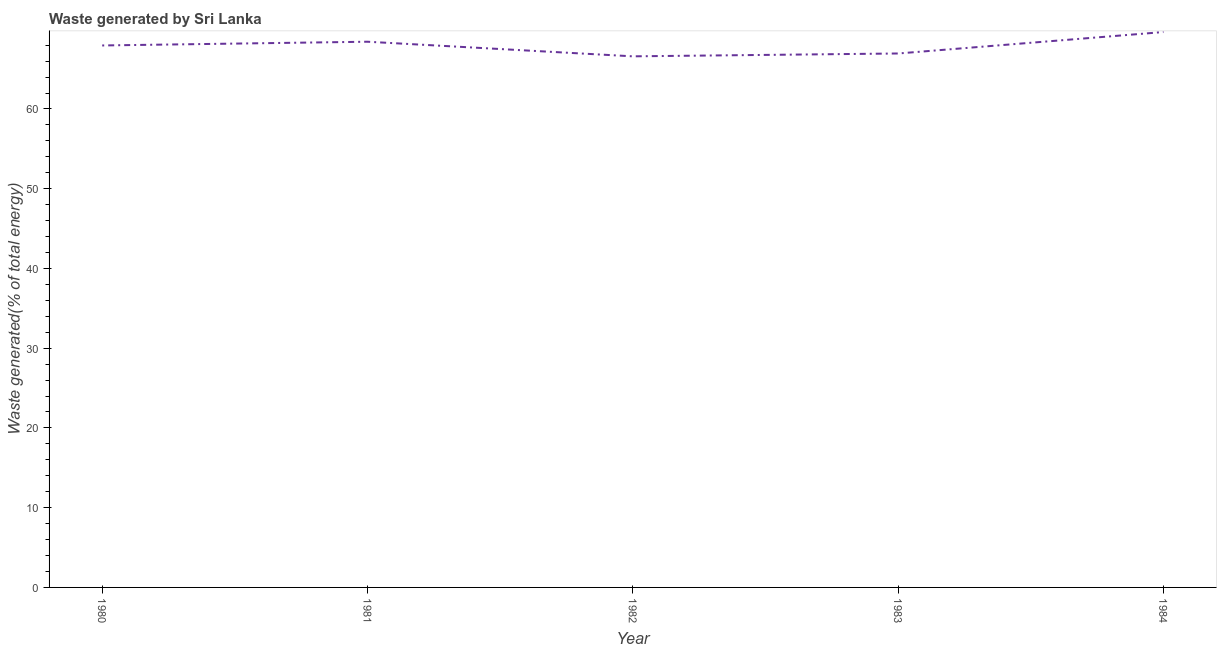What is the amount of waste generated in 1983?
Provide a succinct answer. 66.96. Across all years, what is the maximum amount of waste generated?
Ensure brevity in your answer.  69.64. Across all years, what is the minimum amount of waste generated?
Make the answer very short. 66.6. What is the sum of the amount of waste generated?
Your answer should be very brief. 339.59. What is the difference between the amount of waste generated in 1981 and 1983?
Keep it short and to the point. 1.47. What is the average amount of waste generated per year?
Your answer should be compact. 67.92. What is the median amount of waste generated?
Provide a succinct answer. 67.96. In how many years, is the amount of waste generated greater than 64 %?
Give a very brief answer. 5. What is the ratio of the amount of waste generated in 1982 to that in 1984?
Keep it short and to the point. 0.96. Is the difference between the amount of waste generated in 1980 and 1981 greater than the difference between any two years?
Make the answer very short. No. What is the difference between the highest and the second highest amount of waste generated?
Offer a terse response. 1.21. What is the difference between the highest and the lowest amount of waste generated?
Your response must be concise. 3.05. Does the amount of waste generated monotonically increase over the years?
Your response must be concise. No. How many lines are there?
Your response must be concise. 1. Are the values on the major ticks of Y-axis written in scientific E-notation?
Give a very brief answer. No. Does the graph contain any zero values?
Offer a very short reply. No. What is the title of the graph?
Keep it short and to the point. Waste generated by Sri Lanka. What is the label or title of the X-axis?
Keep it short and to the point. Year. What is the label or title of the Y-axis?
Offer a very short reply. Waste generated(% of total energy). What is the Waste generated(% of total energy) of 1980?
Offer a terse response. 67.96. What is the Waste generated(% of total energy) of 1981?
Your answer should be compact. 68.43. What is the Waste generated(% of total energy) of 1982?
Make the answer very short. 66.6. What is the Waste generated(% of total energy) in 1983?
Your answer should be very brief. 66.96. What is the Waste generated(% of total energy) of 1984?
Provide a succinct answer. 69.64. What is the difference between the Waste generated(% of total energy) in 1980 and 1981?
Provide a short and direct response. -0.47. What is the difference between the Waste generated(% of total energy) in 1980 and 1982?
Offer a terse response. 1.36. What is the difference between the Waste generated(% of total energy) in 1980 and 1983?
Your answer should be very brief. 1.01. What is the difference between the Waste generated(% of total energy) in 1980 and 1984?
Your answer should be very brief. -1.68. What is the difference between the Waste generated(% of total energy) in 1981 and 1982?
Keep it short and to the point. 1.83. What is the difference between the Waste generated(% of total energy) in 1981 and 1983?
Provide a succinct answer. 1.47. What is the difference between the Waste generated(% of total energy) in 1981 and 1984?
Give a very brief answer. -1.21. What is the difference between the Waste generated(% of total energy) in 1982 and 1983?
Your response must be concise. -0.36. What is the difference between the Waste generated(% of total energy) in 1982 and 1984?
Give a very brief answer. -3.05. What is the difference between the Waste generated(% of total energy) in 1983 and 1984?
Give a very brief answer. -2.69. What is the ratio of the Waste generated(% of total energy) in 1980 to that in 1981?
Your answer should be compact. 0.99. What is the ratio of the Waste generated(% of total energy) in 1980 to that in 1982?
Keep it short and to the point. 1.02. What is the ratio of the Waste generated(% of total energy) in 1980 to that in 1983?
Provide a short and direct response. 1.01. What is the ratio of the Waste generated(% of total energy) in 1980 to that in 1984?
Your answer should be compact. 0.98. What is the ratio of the Waste generated(% of total energy) in 1981 to that in 1982?
Provide a succinct answer. 1.03. What is the ratio of the Waste generated(% of total energy) in 1982 to that in 1983?
Keep it short and to the point. 0.99. What is the ratio of the Waste generated(% of total energy) in 1982 to that in 1984?
Make the answer very short. 0.96. What is the ratio of the Waste generated(% of total energy) in 1983 to that in 1984?
Keep it short and to the point. 0.96. 